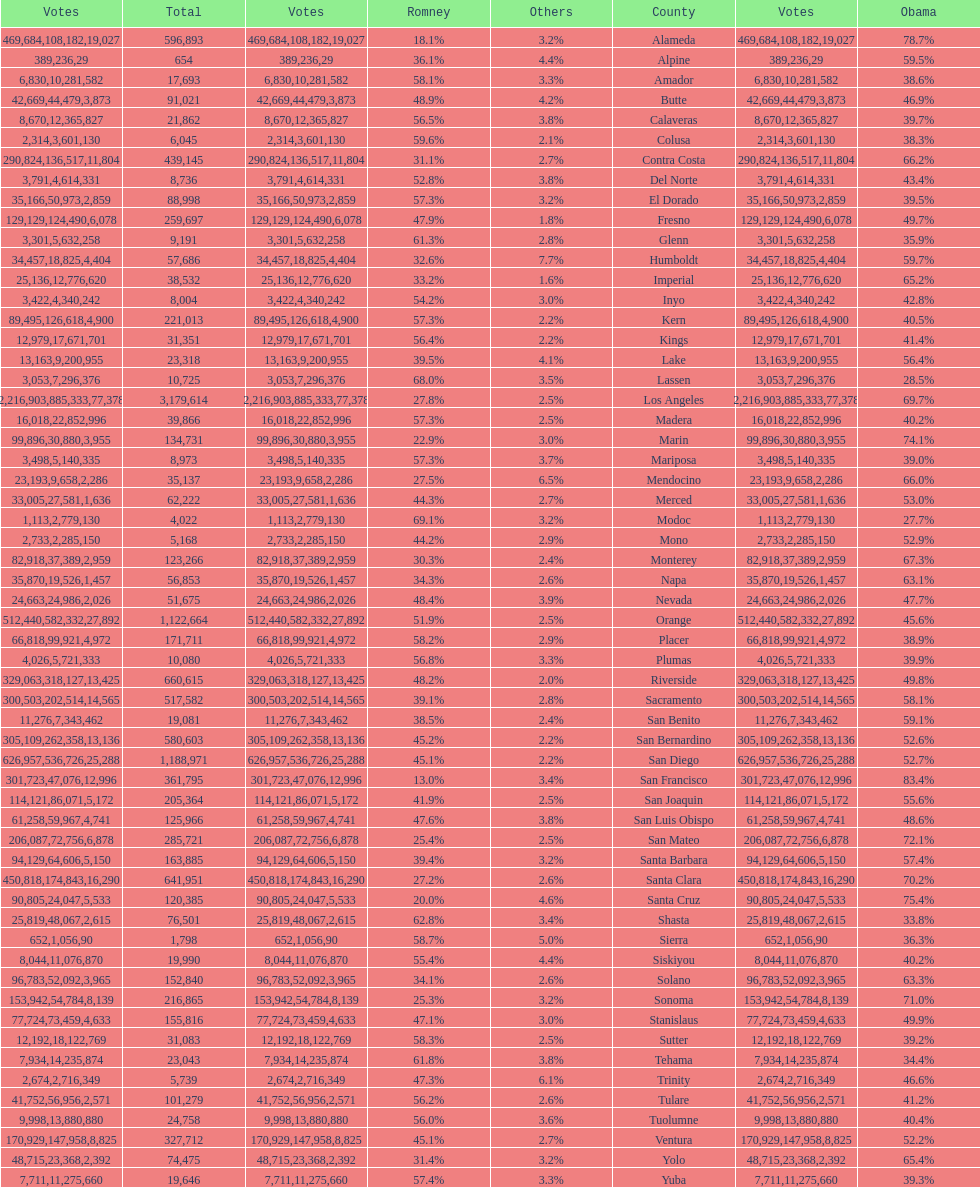What is the total number of votes for amador? 17693. 